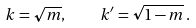Convert formula to latex. <formula><loc_0><loc_0><loc_500><loc_500>k = \sqrt { m } , \quad k ^ { \prime } = \sqrt { 1 - m } \, .</formula> 